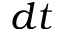<formula> <loc_0><loc_0><loc_500><loc_500>d t</formula> 